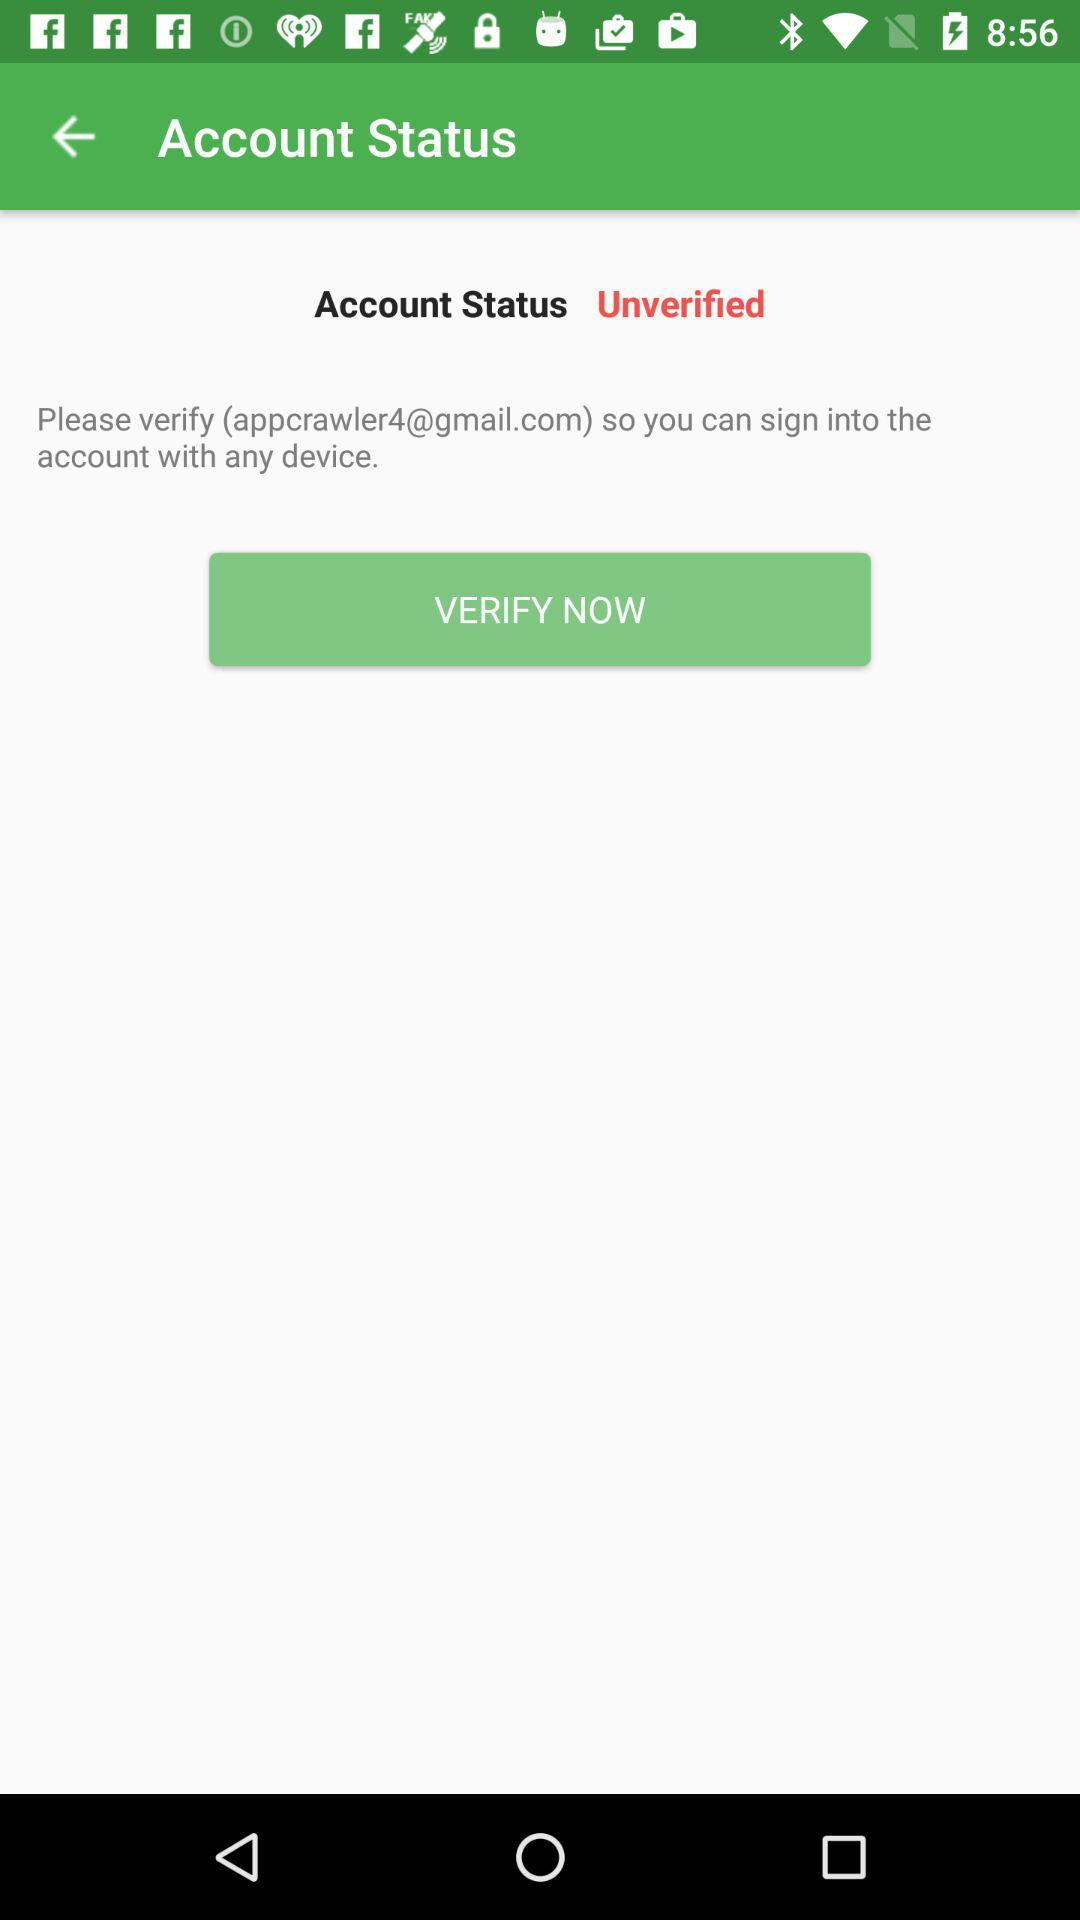What is the Gmail account address? The Gmail account address is appcrawler4@gmail.com. 